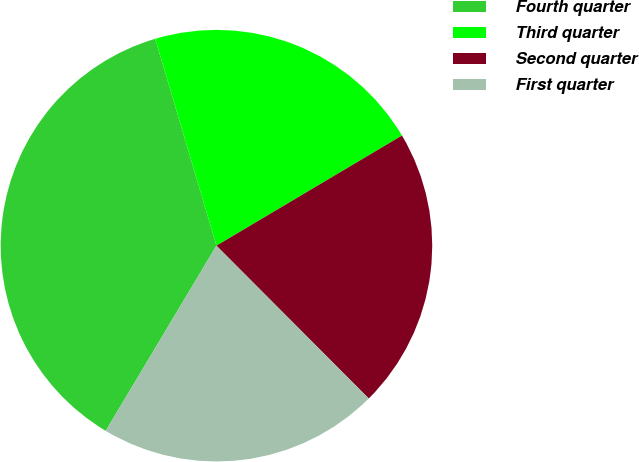<chart> <loc_0><loc_0><loc_500><loc_500><pie_chart><fcel>Fourth quarter<fcel>Third quarter<fcel>Second quarter<fcel>First quarter<nl><fcel>36.84%<fcel>21.05%<fcel>21.05%<fcel>21.05%<nl></chart> 